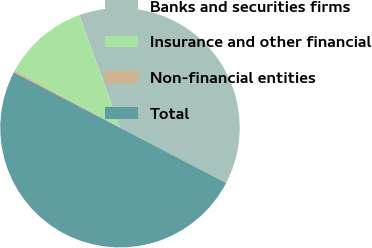Convert chart. <chart><loc_0><loc_0><loc_500><loc_500><pie_chart><fcel>Banks and securities firms<fcel>Insurance and other financial<fcel>Non-financial entities<fcel>Total<nl><fcel>38.14%<fcel>11.59%<fcel>0.27%<fcel>50.0%<nl></chart> 